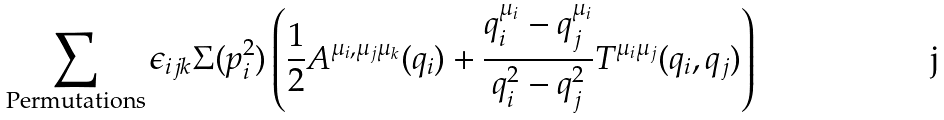Convert formula to latex. <formula><loc_0><loc_0><loc_500><loc_500>\sum _ { \text {Permutations} } \epsilon _ { i j k } \Sigma ( p _ { i } ^ { 2 } ) \left ( \frac { 1 } { 2 } A ^ { \mu _ { i } , \mu _ { j } \mu _ { k } } ( q _ { i } ) + \frac { q _ { i } ^ { \mu _ { i } } - q _ { j } ^ { \mu _ { i } } } { q _ { i } ^ { 2 } - q _ { j } ^ { 2 } } T ^ { \mu _ { i } \mu _ { j } } ( q _ { i } , q _ { j } ) \right )</formula> 